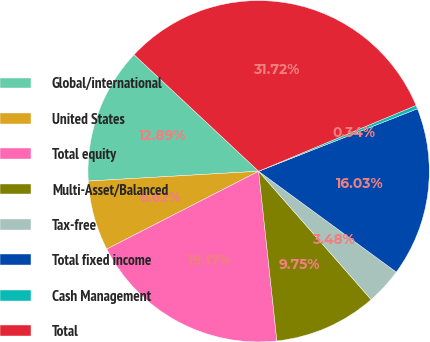<chart> <loc_0><loc_0><loc_500><loc_500><pie_chart><fcel>Global/international<fcel>United States<fcel>Total equity<fcel>Multi-Asset/Balanced<fcel>Tax-free<fcel>Total fixed income<fcel>Cash Management<fcel>Total<nl><fcel>12.89%<fcel>6.62%<fcel>19.17%<fcel>9.75%<fcel>3.48%<fcel>16.03%<fcel>0.34%<fcel>31.72%<nl></chart> 